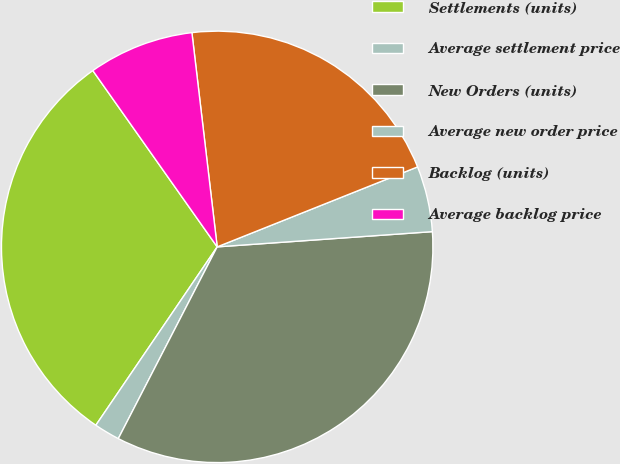<chart> <loc_0><loc_0><loc_500><loc_500><pie_chart><fcel>Settlements (units)<fcel>Average settlement price<fcel>New Orders (units)<fcel>Average new order price<fcel>Backlog (units)<fcel>Average backlog price<nl><fcel>30.72%<fcel>1.93%<fcel>33.71%<fcel>4.92%<fcel>20.83%<fcel>7.91%<nl></chart> 